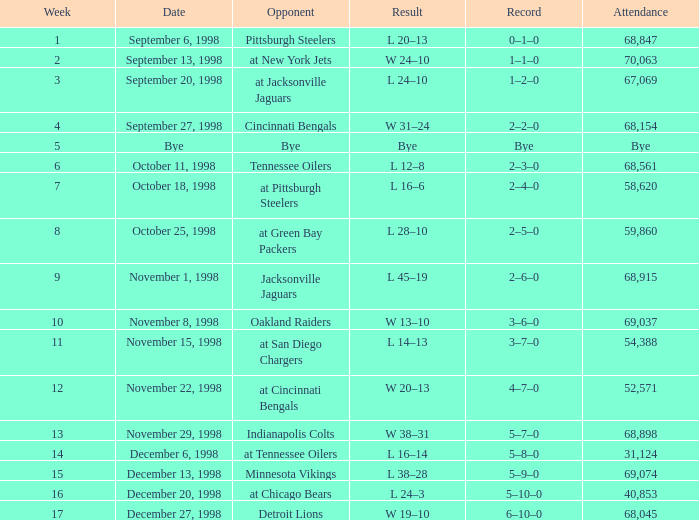Which opponent was played in Week 6? Tennessee Oilers. 